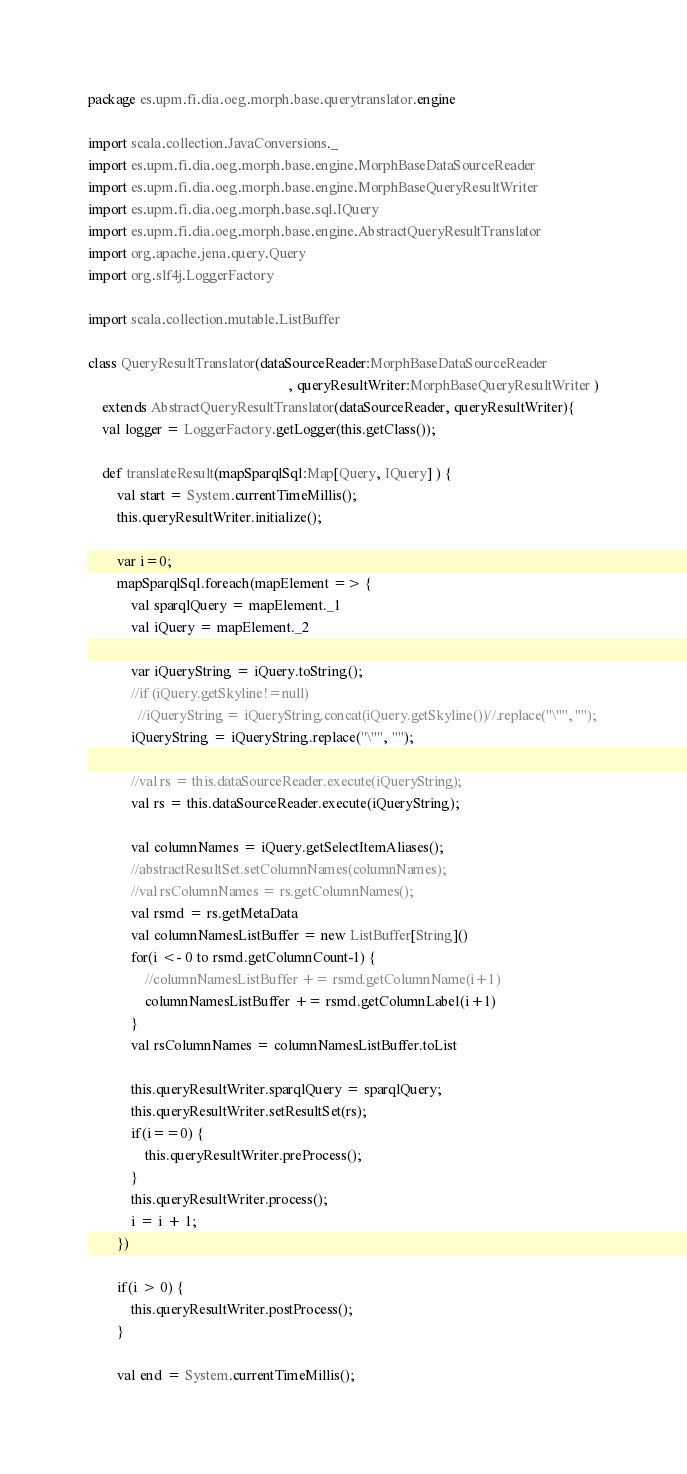Convert code to text. <code><loc_0><loc_0><loc_500><loc_500><_Scala_>package es.upm.fi.dia.oeg.morph.base.querytranslator.engine

import scala.collection.JavaConversions._
import es.upm.fi.dia.oeg.morph.base.engine.MorphBaseDataSourceReader
import es.upm.fi.dia.oeg.morph.base.engine.MorphBaseQueryResultWriter
import es.upm.fi.dia.oeg.morph.base.sql.IQuery
import es.upm.fi.dia.oeg.morph.base.engine.AbstractQueryResultTranslator
import org.apache.jena.query.Query
import org.slf4j.LoggerFactory

import scala.collection.mutable.ListBuffer

class QueryResultTranslator(dataSourceReader:MorphBaseDataSourceReader
														, queryResultWriter:MorphBaseQueryResultWriter )
	extends AbstractQueryResultTranslator(dataSourceReader, queryResultWriter){
	val logger = LoggerFactory.getLogger(this.getClass());

	def translateResult(mapSparqlSql:Map[Query, IQuery] ) {
		val start = System.currentTimeMillis();
		this.queryResultWriter.initialize();

		var i=0;
		mapSparqlSql.foreach(mapElement => {
			val sparqlQuery = mapElement._1
			val iQuery = mapElement._2

			var iQueryString = iQuery.toString();
			//if (iQuery.getSkyline!=null)
			  //iQueryString = iQueryString.concat(iQuery.getSkyline())//.replace("\"", "");
			iQueryString = iQueryString.replace("\"", "");

			//val rs = this.dataSourceReader.execute(iQueryString);
			val rs = this.dataSourceReader.execute(iQueryString);
			
			val columnNames = iQuery.getSelectItemAliases();
			//abstractResultSet.setColumnNames(columnNames);
			//val rsColumnNames = rs.getColumnNames();
			val rsmd = rs.getMetaData
			val columnNamesListBuffer = new ListBuffer[String]()
			for(i <- 0 to rsmd.getColumnCount-1) {
				//columnNamesListBuffer += rsmd.getColumnName(i+1)
				columnNamesListBuffer += rsmd.getColumnLabel(i+1)
			}
			val rsColumnNames = columnNamesListBuffer.toList

			this.queryResultWriter.sparqlQuery = sparqlQuery;
			this.queryResultWriter.setResultSet(rs);
			if(i==0) {
				this.queryResultWriter.preProcess();
			}
			this.queryResultWriter.process();
			i = i + 1;
		})

		if(i > 0) {
			this.queryResultWriter.postProcess();
		}

		val end = System.currentTimeMillis();</code> 